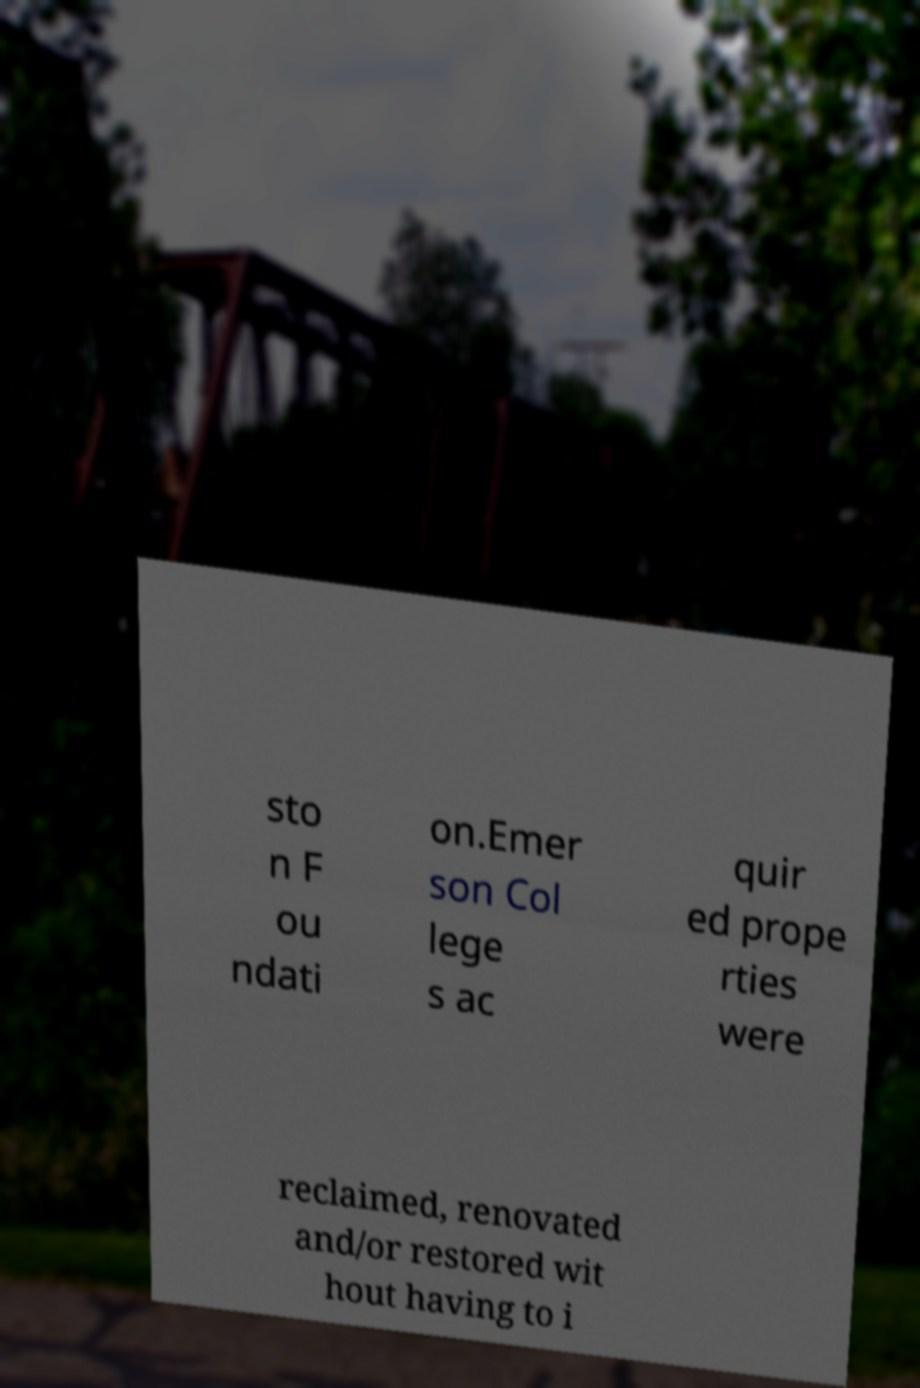Can you accurately transcribe the text from the provided image for me? sto n F ou ndati on.Emer son Col lege s ac quir ed prope rties were reclaimed, renovated and/or restored wit hout having to i 